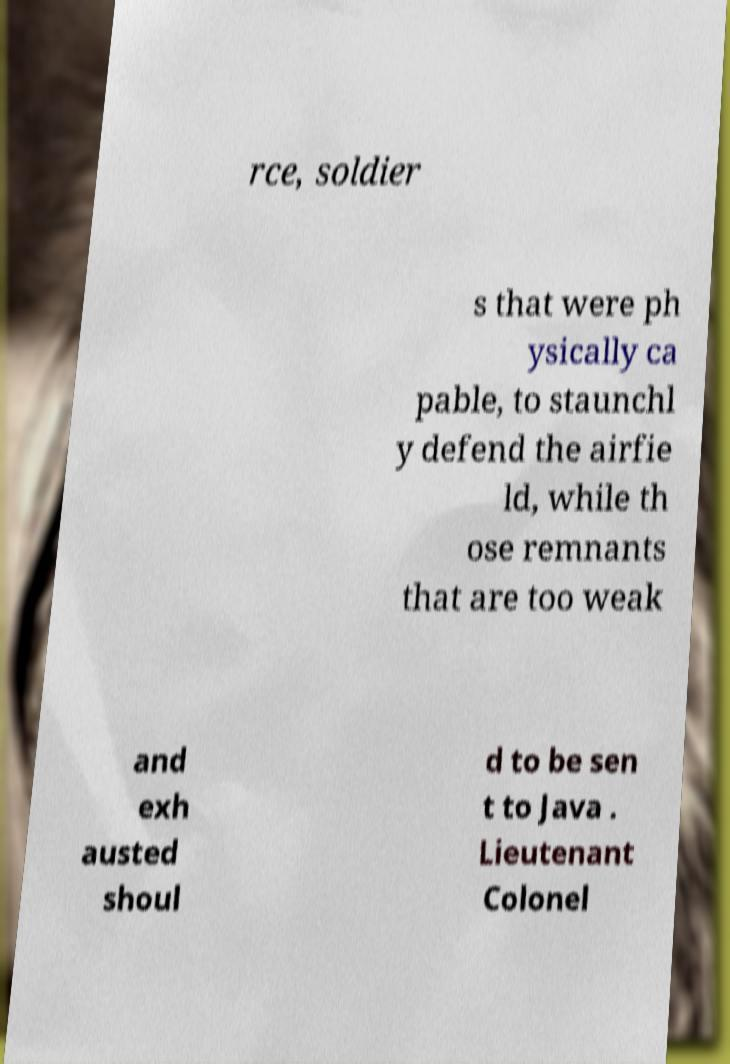Can you read and provide the text displayed in the image?This photo seems to have some interesting text. Can you extract and type it out for me? rce, soldier s that were ph ysically ca pable, to staunchl y defend the airfie ld, while th ose remnants that are too weak and exh austed shoul d to be sen t to Java . Lieutenant Colonel 